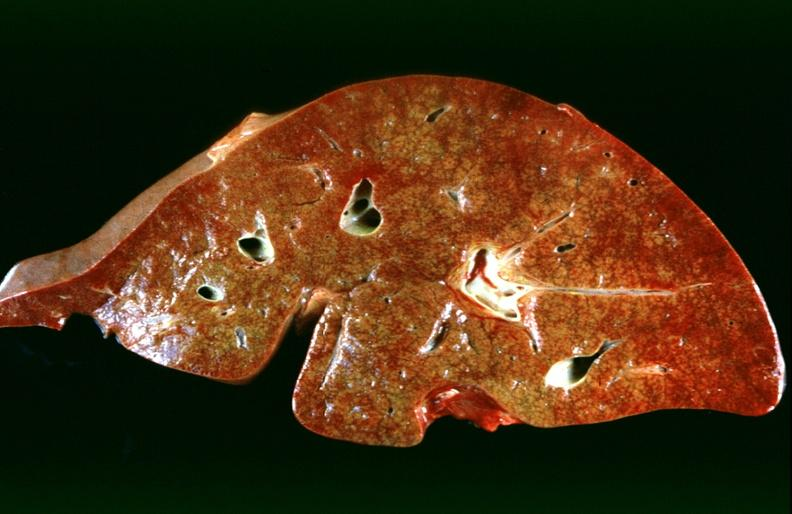s hepatobiliary present?
Answer the question using a single word or phrase. Yes 